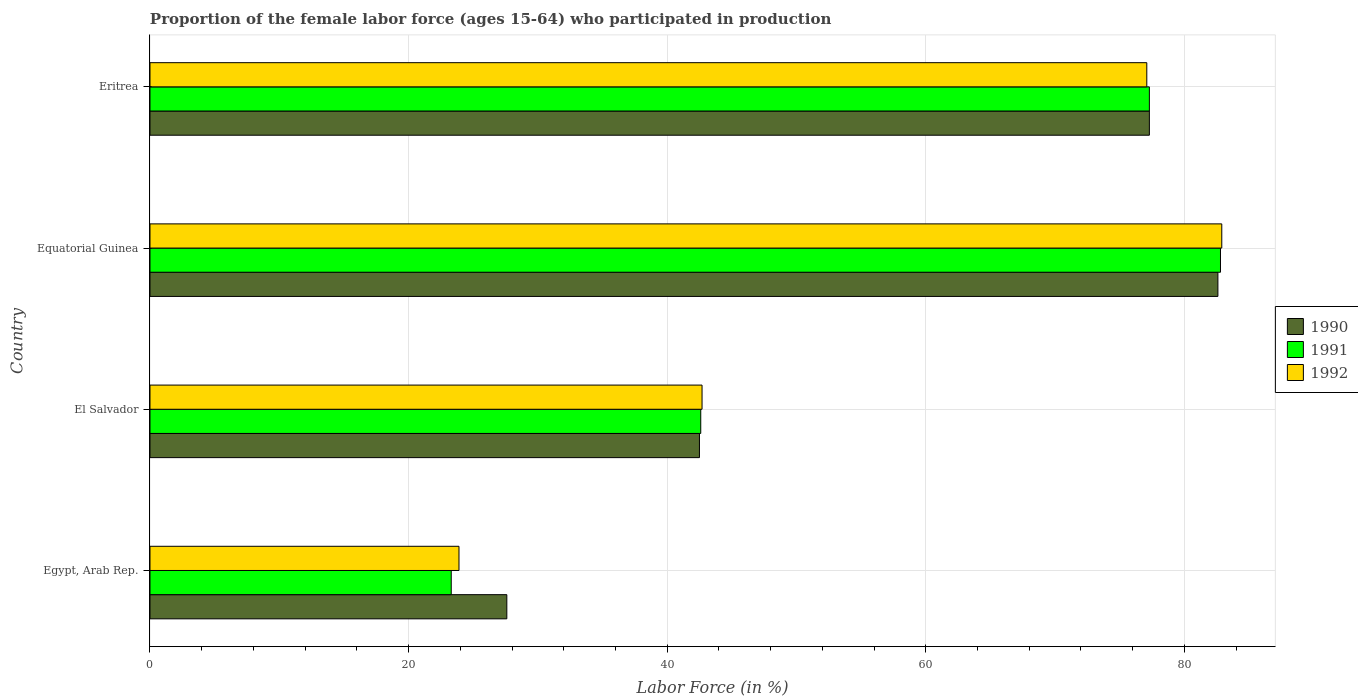Are the number of bars on each tick of the Y-axis equal?
Your answer should be very brief. Yes. How many bars are there on the 2nd tick from the top?
Keep it short and to the point. 3. How many bars are there on the 3rd tick from the bottom?
Ensure brevity in your answer.  3. What is the label of the 2nd group of bars from the top?
Give a very brief answer. Equatorial Guinea. What is the proportion of the female labor force who participated in production in 1991 in El Salvador?
Offer a terse response. 42.6. Across all countries, what is the maximum proportion of the female labor force who participated in production in 1991?
Your answer should be very brief. 82.8. Across all countries, what is the minimum proportion of the female labor force who participated in production in 1991?
Ensure brevity in your answer.  23.3. In which country was the proportion of the female labor force who participated in production in 1990 maximum?
Offer a very short reply. Equatorial Guinea. In which country was the proportion of the female labor force who participated in production in 1992 minimum?
Keep it short and to the point. Egypt, Arab Rep. What is the total proportion of the female labor force who participated in production in 1990 in the graph?
Ensure brevity in your answer.  230. What is the difference between the proportion of the female labor force who participated in production in 1992 in El Salvador and that in Eritrea?
Your answer should be compact. -34.4. What is the difference between the proportion of the female labor force who participated in production in 1992 in Equatorial Guinea and the proportion of the female labor force who participated in production in 1991 in Eritrea?
Provide a succinct answer. 5.6. What is the average proportion of the female labor force who participated in production in 1990 per country?
Provide a short and direct response. 57.5. What is the difference between the proportion of the female labor force who participated in production in 1991 and proportion of the female labor force who participated in production in 1990 in Equatorial Guinea?
Provide a succinct answer. 0.2. What is the ratio of the proportion of the female labor force who participated in production in 1991 in Egypt, Arab Rep. to that in El Salvador?
Make the answer very short. 0.55. Is the proportion of the female labor force who participated in production in 1992 in El Salvador less than that in Equatorial Guinea?
Keep it short and to the point. Yes. What is the difference between the highest and the second highest proportion of the female labor force who participated in production in 1990?
Provide a short and direct response. 5.3. What is the difference between the highest and the lowest proportion of the female labor force who participated in production in 1991?
Your answer should be compact. 59.5. Is it the case that in every country, the sum of the proportion of the female labor force who participated in production in 1991 and proportion of the female labor force who participated in production in 1992 is greater than the proportion of the female labor force who participated in production in 1990?
Provide a short and direct response. Yes. How many bars are there?
Your answer should be compact. 12. Are all the bars in the graph horizontal?
Ensure brevity in your answer.  Yes. What is the difference between two consecutive major ticks on the X-axis?
Give a very brief answer. 20. Are the values on the major ticks of X-axis written in scientific E-notation?
Give a very brief answer. No. How are the legend labels stacked?
Keep it short and to the point. Vertical. What is the title of the graph?
Offer a very short reply. Proportion of the female labor force (ages 15-64) who participated in production. What is the label or title of the X-axis?
Give a very brief answer. Labor Force (in %). What is the label or title of the Y-axis?
Your answer should be compact. Country. What is the Labor Force (in %) in 1990 in Egypt, Arab Rep.?
Keep it short and to the point. 27.6. What is the Labor Force (in %) of 1991 in Egypt, Arab Rep.?
Provide a succinct answer. 23.3. What is the Labor Force (in %) in 1992 in Egypt, Arab Rep.?
Your answer should be very brief. 23.9. What is the Labor Force (in %) in 1990 in El Salvador?
Ensure brevity in your answer.  42.5. What is the Labor Force (in %) in 1991 in El Salvador?
Keep it short and to the point. 42.6. What is the Labor Force (in %) of 1992 in El Salvador?
Make the answer very short. 42.7. What is the Labor Force (in %) in 1990 in Equatorial Guinea?
Offer a very short reply. 82.6. What is the Labor Force (in %) in 1991 in Equatorial Guinea?
Make the answer very short. 82.8. What is the Labor Force (in %) of 1992 in Equatorial Guinea?
Give a very brief answer. 82.9. What is the Labor Force (in %) of 1990 in Eritrea?
Keep it short and to the point. 77.3. What is the Labor Force (in %) of 1991 in Eritrea?
Your answer should be compact. 77.3. What is the Labor Force (in %) in 1992 in Eritrea?
Offer a very short reply. 77.1. Across all countries, what is the maximum Labor Force (in %) of 1990?
Offer a terse response. 82.6. Across all countries, what is the maximum Labor Force (in %) in 1991?
Keep it short and to the point. 82.8. Across all countries, what is the maximum Labor Force (in %) in 1992?
Keep it short and to the point. 82.9. Across all countries, what is the minimum Labor Force (in %) in 1990?
Offer a very short reply. 27.6. Across all countries, what is the minimum Labor Force (in %) of 1991?
Give a very brief answer. 23.3. Across all countries, what is the minimum Labor Force (in %) of 1992?
Provide a short and direct response. 23.9. What is the total Labor Force (in %) in 1990 in the graph?
Make the answer very short. 230. What is the total Labor Force (in %) in 1991 in the graph?
Make the answer very short. 226. What is the total Labor Force (in %) of 1992 in the graph?
Provide a short and direct response. 226.6. What is the difference between the Labor Force (in %) of 1990 in Egypt, Arab Rep. and that in El Salvador?
Offer a terse response. -14.9. What is the difference between the Labor Force (in %) of 1991 in Egypt, Arab Rep. and that in El Salvador?
Your answer should be very brief. -19.3. What is the difference between the Labor Force (in %) of 1992 in Egypt, Arab Rep. and that in El Salvador?
Your answer should be compact. -18.8. What is the difference between the Labor Force (in %) of 1990 in Egypt, Arab Rep. and that in Equatorial Guinea?
Make the answer very short. -55. What is the difference between the Labor Force (in %) of 1991 in Egypt, Arab Rep. and that in Equatorial Guinea?
Provide a short and direct response. -59.5. What is the difference between the Labor Force (in %) of 1992 in Egypt, Arab Rep. and that in Equatorial Guinea?
Ensure brevity in your answer.  -59. What is the difference between the Labor Force (in %) in 1990 in Egypt, Arab Rep. and that in Eritrea?
Your response must be concise. -49.7. What is the difference between the Labor Force (in %) in 1991 in Egypt, Arab Rep. and that in Eritrea?
Offer a terse response. -54. What is the difference between the Labor Force (in %) in 1992 in Egypt, Arab Rep. and that in Eritrea?
Your answer should be compact. -53.2. What is the difference between the Labor Force (in %) of 1990 in El Salvador and that in Equatorial Guinea?
Your response must be concise. -40.1. What is the difference between the Labor Force (in %) in 1991 in El Salvador and that in Equatorial Guinea?
Your answer should be compact. -40.2. What is the difference between the Labor Force (in %) in 1992 in El Salvador and that in Equatorial Guinea?
Your response must be concise. -40.2. What is the difference between the Labor Force (in %) of 1990 in El Salvador and that in Eritrea?
Keep it short and to the point. -34.8. What is the difference between the Labor Force (in %) of 1991 in El Salvador and that in Eritrea?
Offer a very short reply. -34.7. What is the difference between the Labor Force (in %) of 1992 in El Salvador and that in Eritrea?
Your response must be concise. -34.4. What is the difference between the Labor Force (in %) of 1990 in Egypt, Arab Rep. and the Labor Force (in %) of 1992 in El Salvador?
Keep it short and to the point. -15.1. What is the difference between the Labor Force (in %) in 1991 in Egypt, Arab Rep. and the Labor Force (in %) in 1992 in El Salvador?
Keep it short and to the point. -19.4. What is the difference between the Labor Force (in %) of 1990 in Egypt, Arab Rep. and the Labor Force (in %) of 1991 in Equatorial Guinea?
Provide a short and direct response. -55.2. What is the difference between the Labor Force (in %) in 1990 in Egypt, Arab Rep. and the Labor Force (in %) in 1992 in Equatorial Guinea?
Ensure brevity in your answer.  -55.3. What is the difference between the Labor Force (in %) in 1991 in Egypt, Arab Rep. and the Labor Force (in %) in 1992 in Equatorial Guinea?
Offer a very short reply. -59.6. What is the difference between the Labor Force (in %) in 1990 in Egypt, Arab Rep. and the Labor Force (in %) in 1991 in Eritrea?
Offer a terse response. -49.7. What is the difference between the Labor Force (in %) in 1990 in Egypt, Arab Rep. and the Labor Force (in %) in 1992 in Eritrea?
Ensure brevity in your answer.  -49.5. What is the difference between the Labor Force (in %) of 1991 in Egypt, Arab Rep. and the Labor Force (in %) of 1992 in Eritrea?
Make the answer very short. -53.8. What is the difference between the Labor Force (in %) of 1990 in El Salvador and the Labor Force (in %) of 1991 in Equatorial Guinea?
Ensure brevity in your answer.  -40.3. What is the difference between the Labor Force (in %) of 1990 in El Salvador and the Labor Force (in %) of 1992 in Equatorial Guinea?
Offer a terse response. -40.4. What is the difference between the Labor Force (in %) in 1991 in El Salvador and the Labor Force (in %) in 1992 in Equatorial Guinea?
Keep it short and to the point. -40.3. What is the difference between the Labor Force (in %) of 1990 in El Salvador and the Labor Force (in %) of 1991 in Eritrea?
Provide a short and direct response. -34.8. What is the difference between the Labor Force (in %) in 1990 in El Salvador and the Labor Force (in %) in 1992 in Eritrea?
Offer a very short reply. -34.6. What is the difference between the Labor Force (in %) in 1991 in El Salvador and the Labor Force (in %) in 1992 in Eritrea?
Your answer should be very brief. -34.5. What is the difference between the Labor Force (in %) in 1990 in Equatorial Guinea and the Labor Force (in %) in 1991 in Eritrea?
Offer a very short reply. 5.3. What is the difference between the Labor Force (in %) of 1990 in Equatorial Guinea and the Labor Force (in %) of 1992 in Eritrea?
Your answer should be compact. 5.5. What is the average Labor Force (in %) of 1990 per country?
Make the answer very short. 57.5. What is the average Labor Force (in %) in 1991 per country?
Your response must be concise. 56.5. What is the average Labor Force (in %) of 1992 per country?
Provide a short and direct response. 56.65. What is the difference between the Labor Force (in %) of 1990 and Labor Force (in %) of 1991 in Egypt, Arab Rep.?
Ensure brevity in your answer.  4.3. What is the difference between the Labor Force (in %) in 1990 and Labor Force (in %) in 1991 in El Salvador?
Your response must be concise. -0.1. What is the difference between the Labor Force (in %) in 1990 and Labor Force (in %) in 1992 in El Salvador?
Keep it short and to the point. -0.2. What is the difference between the Labor Force (in %) in 1990 and Labor Force (in %) in 1992 in Equatorial Guinea?
Provide a short and direct response. -0.3. What is the difference between the Labor Force (in %) in 1990 and Labor Force (in %) in 1991 in Eritrea?
Your response must be concise. 0. What is the difference between the Labor Force (in %) in 1991 and Labor Force (in %) in 1992 in Eritrea?
Offer a very short reply. 0.2. What is the ratio of the Labor Force (in %) in 1990 in Egypt, Arab Rep. to that in El Salvador?
Make the answer very short. 0.65. What is the ratio of the Labor Force (in %) of 1991 in Egypt, Arab Rep. to that in El Salvador?
Ensure brevity in your answer.  0.55. What is the ratio of the Labor Force (in %) of 1992 in Egypt, Arab Rep. to that in El Salvador?
Provide a succinct answer. 0.56. What is the ratio of the Labor Force (in %) in 1990 in Egypt, Arab Rep. to that in Equatorial Guinea?
Make the answer very short. 0.33. What is the ratio of the Labor Force (in %) of 1991 in Egypt, Arab Rep. to that in Equatorial Guinea?
Give a very brief answer. 0.28. What is the ratio of the Labor Force (in %) of 1992 in Egypt, Arab Rep. to that in Equatorial Guinea?
Ensure brevity in your answer.  0.29. What is the ratio of the Labor Force (in %) in 1990 in Egypt, Arab Rep. to that in Eritrea?
Provide a short and direct response. 0.36. What is the ratio of the Labor Force (in %) in 1991 in Egypt, Arab Rep. to that in Eritrea?
Provide a succinct answer. 0.3. What is the ratio of the Labor Force (in %) of 1992 in Egypt, Arab Rep. to that in Eritrea?
Your response must be concise. 0.31. What is the ratio of the Labor Force (in %) in 1990 in El Salvador to that in Equatorial Guinea?
Your answer should be very brief. 0.51. What is the ratio of the Labor Force (in %) of 1991 in El Salvador to that in Equatorial Guinea?
Your response must be concise. 0.51. What is the ratio of the Labor Force (in %) of 1992 in El Salvador to that in Equatorial Guinea?
Offer a very short reply. 0.52. What is the ratio of the Labor Force (in %) of 1990 in El Salvador to that in Eritrea?
Your answer should be very brief. 0.55. What is the ratio of the Labor Force (in %) of 1991 in El Salvador to that in Eritrea?
Your response must be concise. 0.55. What is the ratio of the Labor Force (in %) of 1992 in El Salvador to that in Eritrea?
Give a very brief answer. 0.55. What is the ratio of the Labor Force (in %) of 1990 in Equatorial Guinea to that in Eritrea?
Offer a very short reply. 1.07. What is the ratio of the Labor Force (in %) in 1991 in Equatorial Guinea to that in Eritrea?
Provide a short and direct response. 1.07. What is the ratio of the Labor Force (in %) of 1992 in Equatorial Guinea to that in Eritrea?
Ensure brevity in your answer.  1.08. What is the difference between the highest and the second highest Labor Force (in %) in 1990?
Keep it short and to the point. 5.3. What is the difference between the highest and the lowest Labor Force (in %) in 1990?
Your answer should be compact. 55. What is the difference between the highest and the lowest Labor Force (in %) in 1991?
Ensure brevity in your answer.  59.5. 